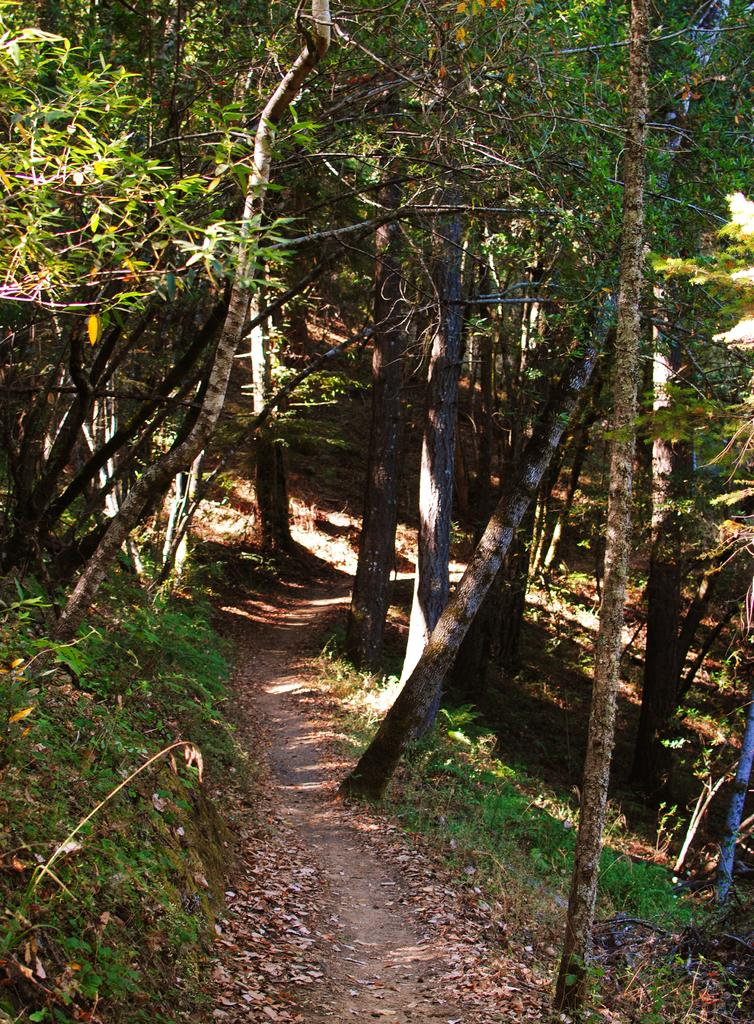What type of environment is shown in the image? The image depicts a forest. What can be observed about the trees in the forest? There are dense trees in the forest. Is there any path or walkway visible in the image? Yes, there is a walkway between the trees. How many legs can be seen in the image? There are no legs visible in the image, as it depicts a forest. 